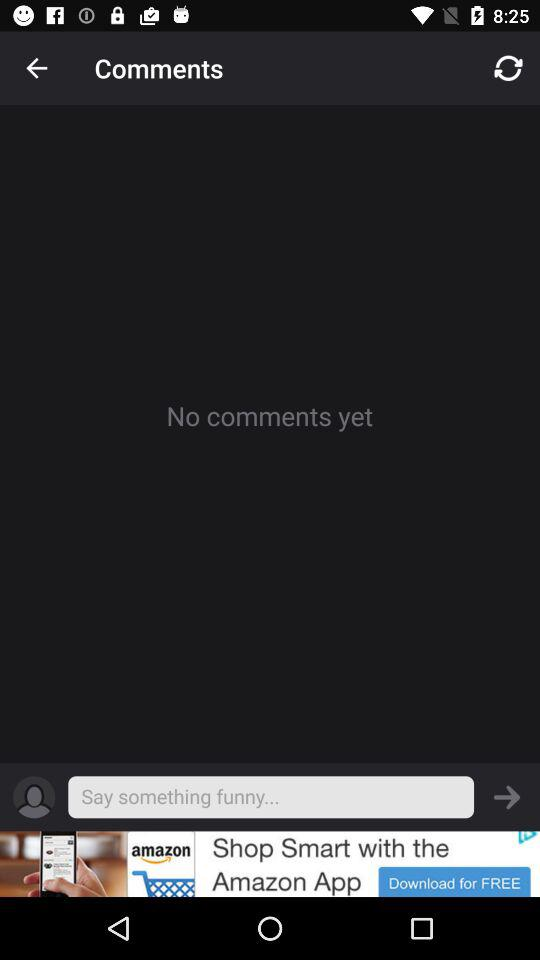Is there any comment? There is no comment. 